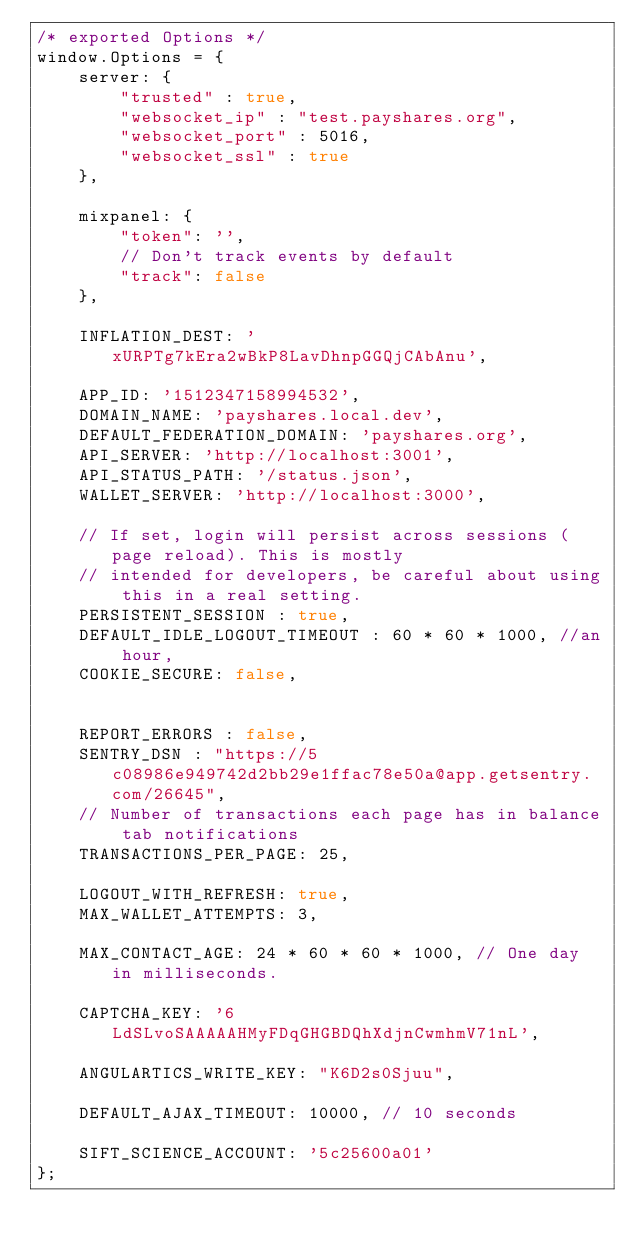Convert code to text. <code><loc_0><loc_0><loc_500><loc_500><_JavaScript_>/* exported Options */
window.Options = {
    server: {
        "trusted" : true,
        "websocket_ip" : "test.payshares.org",
        "websocket_port" : 5016,
        "websocket_ssl" : true
    },

    mixpanel: {
        "token": '',
        // Don't track events by default
        "track": false
    },

    INFLATION_DEST: 'xURPTg7kEra2wBkP8LavDhnpGGQjCAbAnu',

    APP_ID: '1512347158994532',
    DOMAIN_NAME: 'payshares.local.dev',
    DEFAULT_FEDERATION_DOMAIN: 'payshares.org',
    API_SERVER: 'http://localhost:3001',
    API_STATUS_PATH: '/status.json',
    WALLET_SERVER: 'http://localhost:3000',

    // If set, login will persist across sessions (page reload). This is mostly
    // intended for developers, be careful about using this in a real setting.
    PERSISTENT_SESSION : true,
    DEFAULT_IDLE_LOGOUT_TIMEOUT : 60 * 60 * 1000, //an hour,
    COOKIE_SECURE: false,


    REPORT_ERRORS : false,
    SENTRY_DSN : "https://5c08986e949742d2bb29e1ffac78e50a@app.getsentry.com/26645",
    // Number of transactions each page has in balance tab notifications
    TRANSACTIONS_PER_PAGE: 25,

    LOGOUT_WITH_REFRESH: true,
    MAX_WALLET_ATTEMPTS: 3,

    MAX_CONTACT_AGE: 24 * 60 * 60 * 1000, // One day in milliseconds.

    CAPTCHA_KEY: '6LdSLvoSAAAAAHMyFDqGHGBDQhXdjnCwmhmV71nL',

    ANGULARTICS_WRITE_KEY: "K6D2s0Sjuu",

    DEFAULT_AJAX_TIMEOUT: 10000, // 10 seconds

    SIFT_SCIENCE_ACCOUNT: '5c25600a01'
};
</code> 